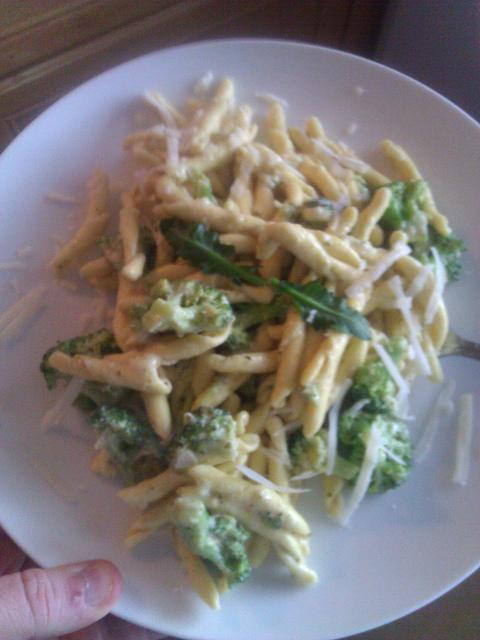Why is the leaf on top?

Choices:
A) preservative
B) color
C) seasoning
D) garnish garnish 